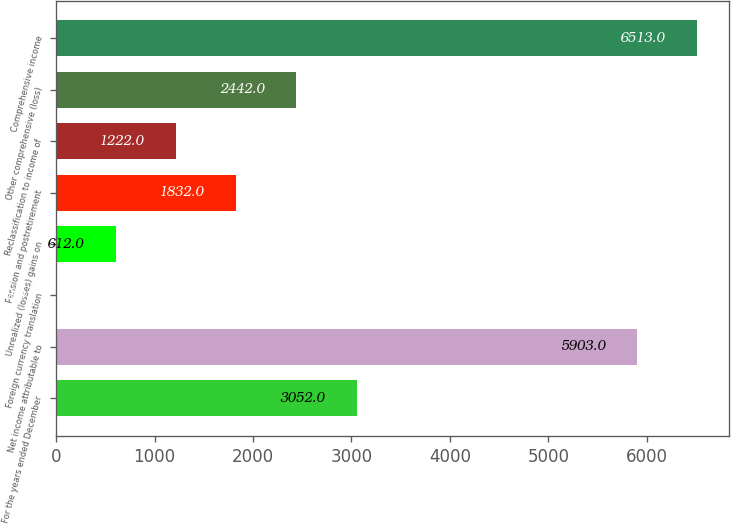<chart> <loc_0><loc_0><loc_500><loc_500><bar_chart><fcel>For the years ended December<fcel>Net income attributable to<fcel>Foreign currency translation<fcel>Unrealized (losses) gains on<fcel>Pension and postretirement<fcel>Reclassification to income of<fcel>Other comprehensive (loss)<fcel>Comprehensive income<nl><fcel>3052<fcel>5903<fcel>2<fcel>612<fcel>1832<fcel>1222<fcel>2442<fcel>6513<nl></chart> 